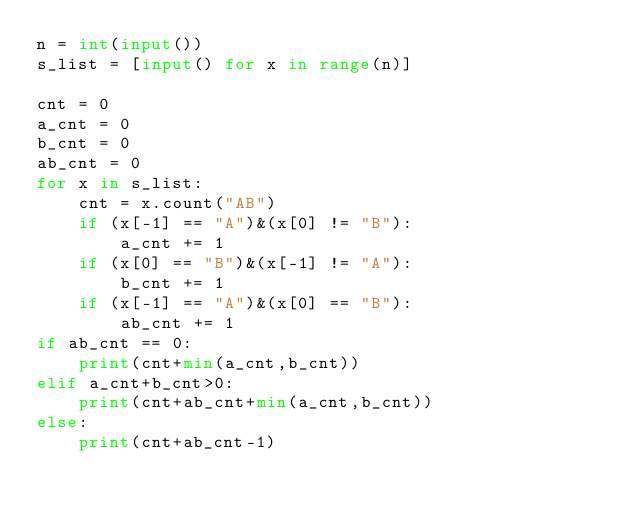Convert code to text. <code><loc_0><loc_0><loc_500><loc_500><_Python_>n = int(input())
s_list = [input() for x in range(n)]

cnt = 0
a_cnt = 0
b_cnt = 0
ab_cnt = 0
for x in s_list:
    cnt = x.count("AB")
    if (x[-1] == "A")&(x[0] != "B"):
        a_cnt += 1
    if (x[0] == "B")&(x[-1] != "A"):
        b_cnt += 1
    if (x[-1] == "A")&(x[0] == "B"):
        ab_cnt += 1
if ab_cnt == 0:
    print(cnt+min(a_cnt,b_cnt))
elif a_cnt+b_cnt>0:
    print(cnt+ab_cnt+min(a_cnt,b_cnt))
else:
    print(cnt+ab_cnt-1)</code> 